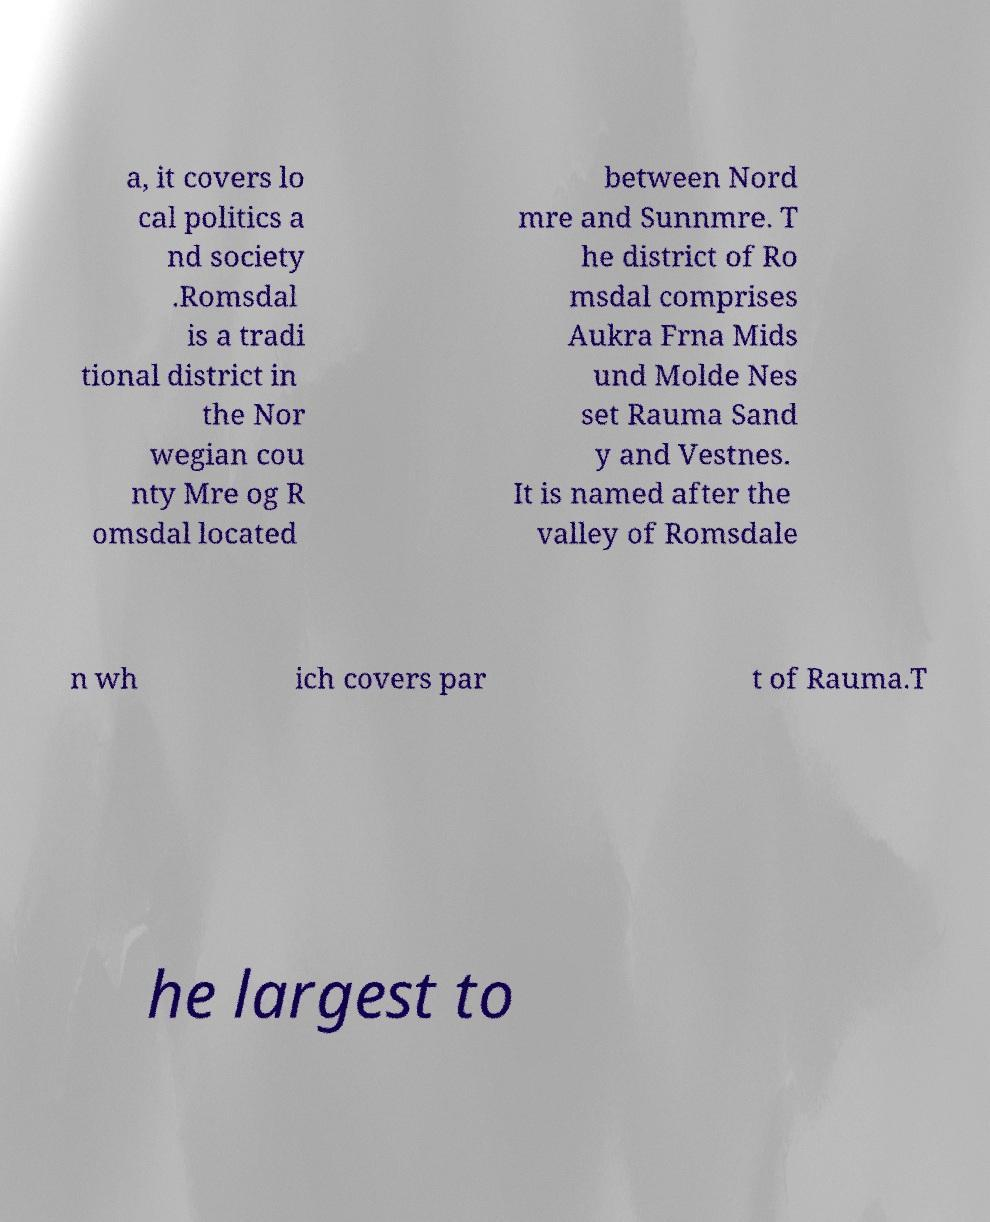Could you extract and type out the text from this image? a, it covers lo cal politics a nd society .Romsdal is a tradi tional district in the Nor wegian cou nty Mre og R omsdal located between Nord mre and Sunnmre. T he district of Ro msdal comprises Aukra Frna Mids und Molde Nes set Rauma Sand y and Vestnes. It is named after the valley of Romsdale n wh ich covers par t of Rauma.T he largest to 